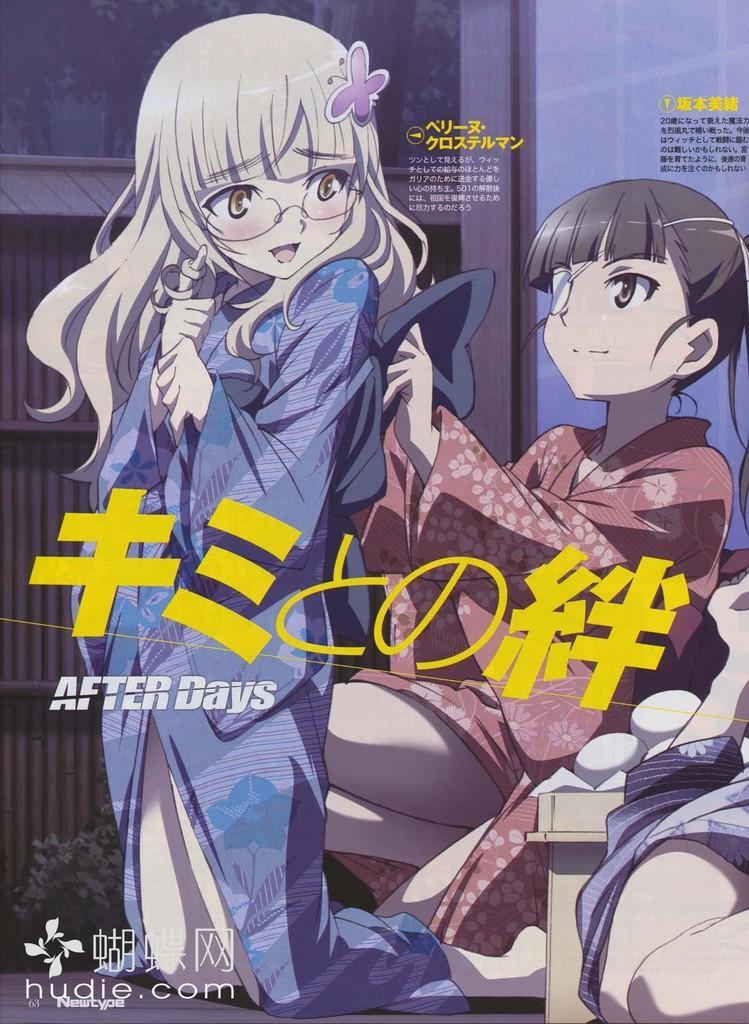In one or two sentences, can you explain what this image depicts? In this picture I can see e cartoon images and I can see text on the picture and I can see text at the bottom left corner of the picture. 